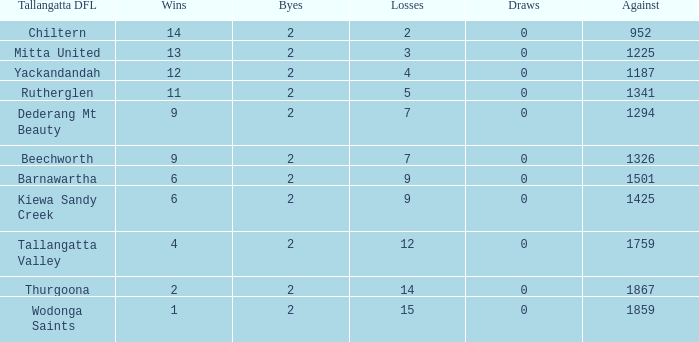How many losses are there when 9 games are won and more than 1326 are lost? None. 